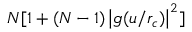<formula> <loc_0><loc_0><loc_500><loc_500>N [ 1 + ( N - 1 ) \left | g ( u / r _ { c } ) \right | ^ { 2 } ]</formula> 